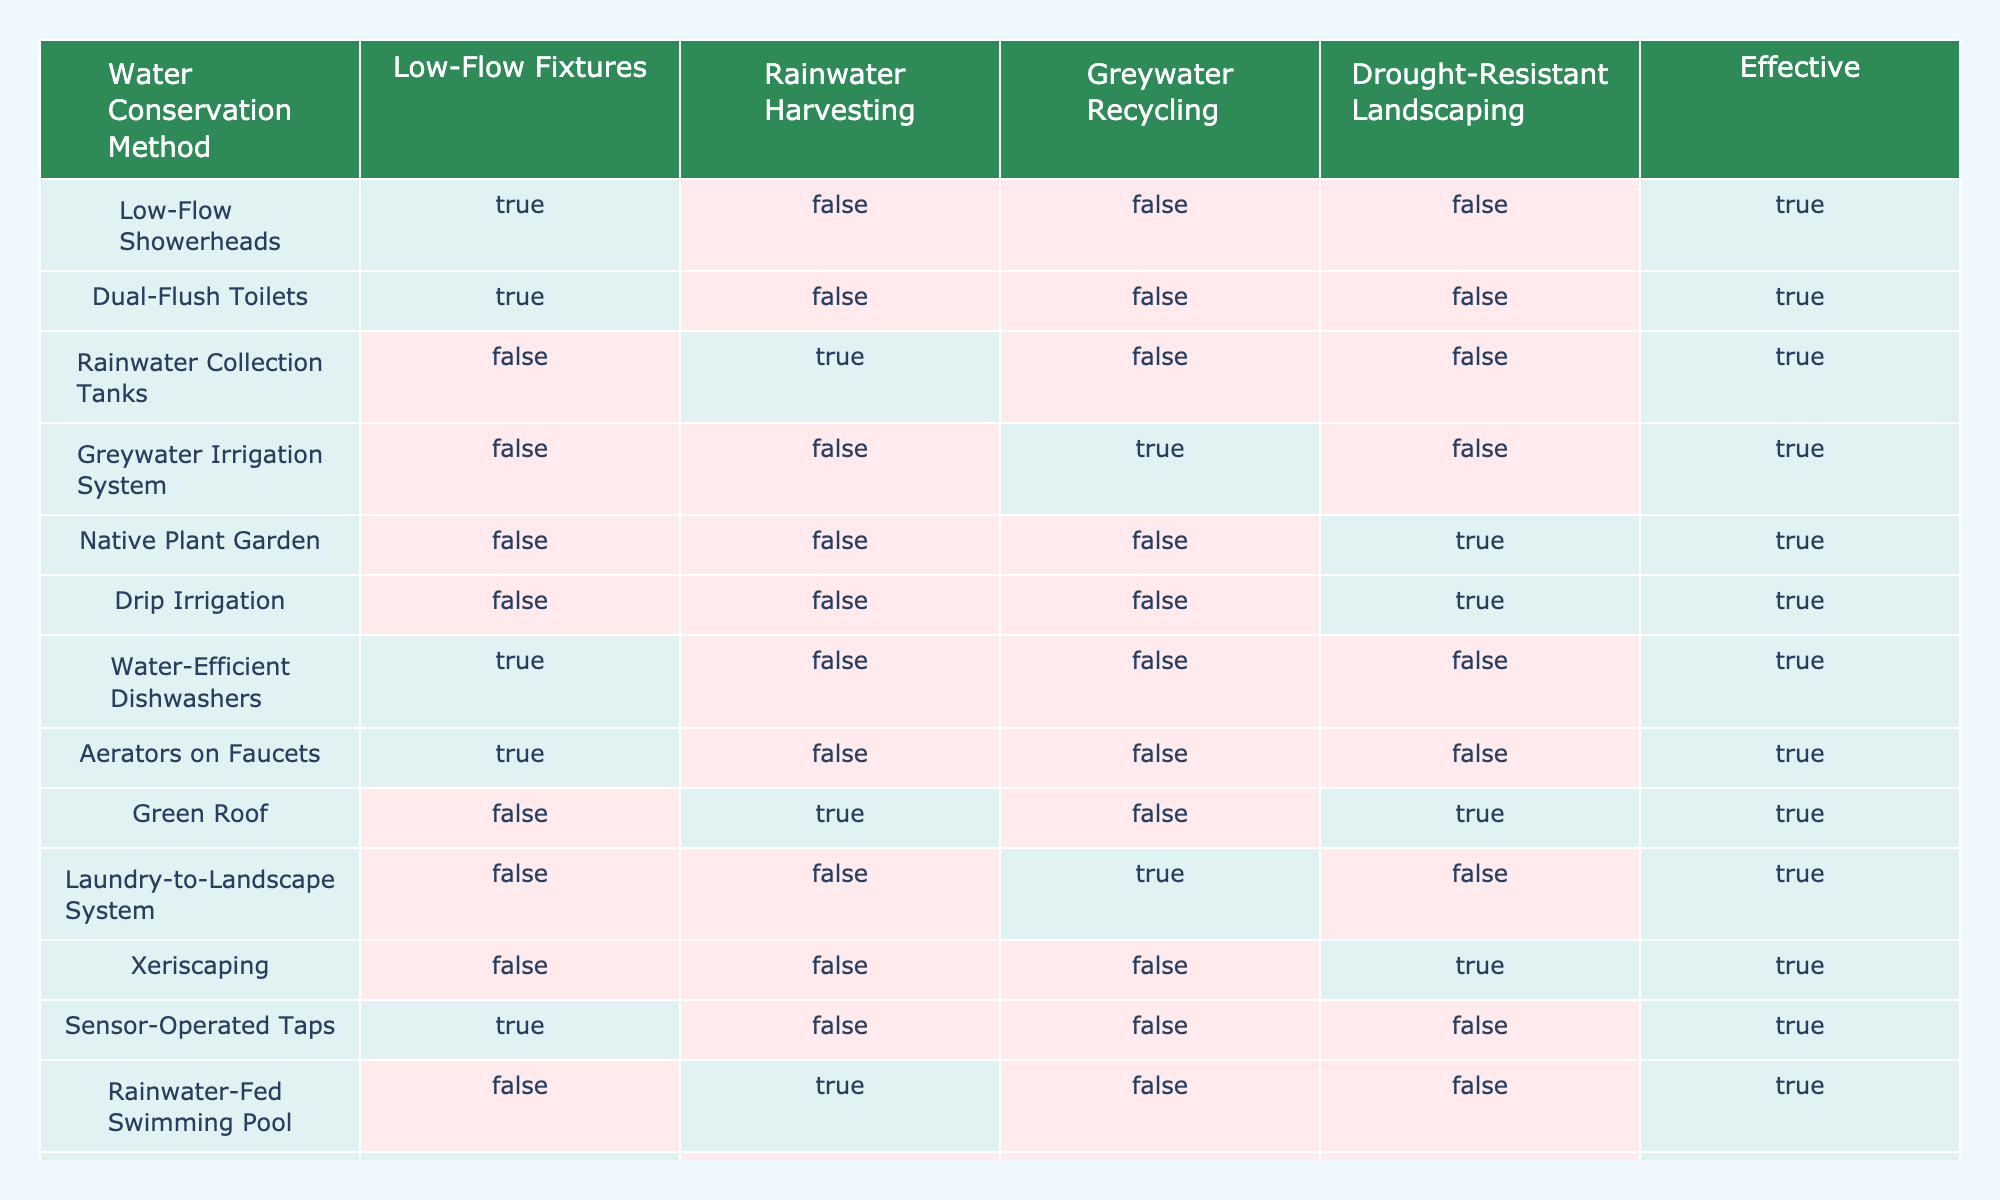What is the water conservation method that involves using less water in toilets? The table shows two methods labeled "Dual-Flush Toilets" and "Composting Toilets," both marked as effective conservation methods.
Answer: Dual-Flush Toilets How many methods in the table utilize rainwater harvesting? The table lists "Rainwater Collection Tanks" and "Green Roof" as methods that effectively utilize rainwater harvesting. Therefore, there are 2 methods.
Answer: 2 Do low-flow showerheads contribute to effective water conservation? According to the table, "Low-Flow Showerheads" is marked as effective, indicating that they contribute to water conservation.
Answer: Yes Which water conservation method is associated with drought-resistant landscaping? The table shows methods like "Native Plant Garden," "Drip Irrigation," "Xeriscaping," and "Mulching," all of which are effective conservation methods associated with drought-resistant landscaping.
Answer: Native Plant Garden, Drip Irrigation, Xeriscaping, Mulching What is the total number of methods that are marked as effective? The table contains 13 methods, and by counting the ones marked as effective, we confirm that 13 methods are effective overall.
Answer: 13 Is it true that Greywater Recycling is an effective method in the table? The table provides "Greywater Irrigation System" under Greywater Recycling, which is marked as effective, confirming that it is indeed an effective method.
Answer: Yes Which methods do not use low-flow fixtures but are still effective? From the table, the effective methods that do not include low-flow fixtures are "Rainwater Collection Tanks," "Greywater Irrigation System," "Native Plant Garden," "Drip Irrigation," "Green Roof," and "Laundry-to-Landscape System" totaling 6 methods.
Answer: 6 Among all methods listed, which is the only one solely focused on composting? The only effective method listed that pertains exclusively to composting is "Composting Toilets," as identified in the table.
Answer: Composting Toilets How does the effectiveness of rainwater-fed swimming pools compare with rainwater harvesting methods? The "Rainwater-Fed Swimming Pool" method is noted to utilize rainwater, and is marked as effective, just like "Rainwater Collection Tanks" and "Green Roof." So, it is also effective.
Answer: They are both effective 